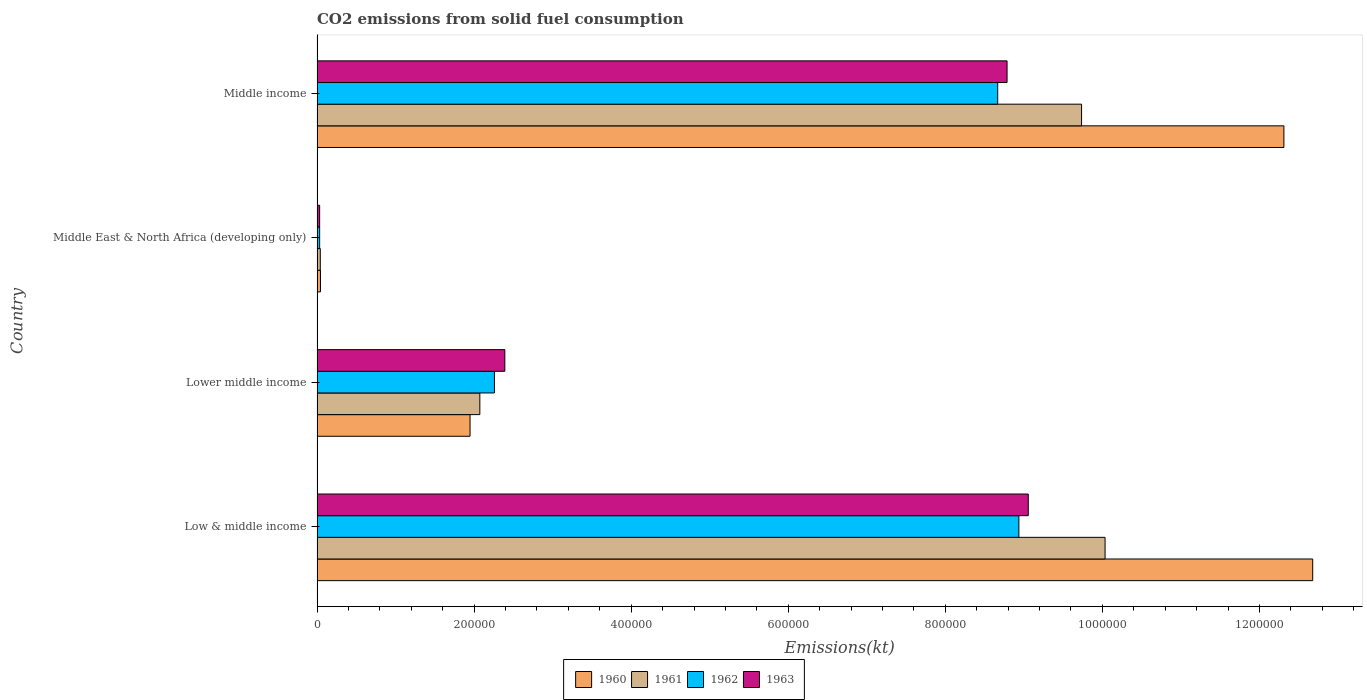Are the number of bars on each tick of the Y-axis equal?
Give a very brief answer. Yes. How many bars are there on the 1st tick from the bottom?
Provide a succinct answer. 4. In how many cases, is the number of bars for a given country not equal to the number of legend labels?
Your answer should be compact. 0. What is the amount of CO2 emitted in 1962 in Middle income?
Make the answer very short. 8.67e+05. Across all countries, what is the maximum amount of CO2 emitted in 1963?
Provide a succinct answer. 9.06e+05. Across all countries, what is the minimum amount of CO2 emitted in 1962?
Your response must be concise. 3311.16. In which country was the amount of CO2 emitted in 1961 minimum?
Your answer should be very brief. Middle East & North Africa (developing only). What is the total amount of CO2 emitted in 1962 in the graph?
Keep it short and to the point. 1.99e+06. What is the difference between the amount of CO2 emitted in 1961 in Low & middle income and that in Middle income?
Ensure brevity in your answer.  2.99e+04. What is the difference between the amount of CO2 emitted in 1962 in Middle income and the amount of CO2 emitted in 1960 in Middle East & North Africa (developing only)?
Your answer should be compact. 8.62e+05. What is the average amount of CO2 emitted in 1960 per country?
Make the answer very short. 6.75e+05. What is the difference between the amount of CO2 emitted in 1962 and amount of CO2 emitted in 1963 in Middle East & North Africa (developing only)?
Provide a succinct answer. 9.42. In how many countries, is the amount of CO2 emitted in 1963 greater than 240000 kt?
Your response must be concise. 2. What is the ratio of the amount of CO2 emitted in 1961 in Low & middle income to that in Middle East & North Africa (developing only)?
Your answer should be very brief. 244.6. What is the difference between the highest and the second highest amount of CO2 emitted in 1962?
Offer a terse response. 2.70e+04. What is the difference between the highest and the lowest amount of CO2 emitted in 1961?
Give a very brief answer. 9.99e+05. In how many countries, is the amount of CO2 emitted in 1963 greater than the average amount of CO2 emitted in 1963 taken over all countries?
Your response must be concise. 2. Is the sum of the amount of CO2 emitted in 1963 in Lower middle income and Middle East & North Africa (developing only) greater than the maximum amount of CO2 emitted in 1962 across all countries?
Make the answer very short. No. Is it the case that in every country, the sum of the amount of CO2 emitted in 1960 and amount of CO2 emitted in 1962 is greater than the sum of amount of CO2 emitted in 1963 and amount of CO2 emitted in 1961?
Offer a very short reply. No. Is it the case that in every country, the sum of the amount of CO2 emitted in 1960 and amount of CO2 emitted in 1961 is greater than the amount of CO2 emitted in 1963?
Keep it short and to the point. Yes. How many bars are there?
Your response must be concise. 16. Does the graph contain any zero values?
Offer a terse response. No. Where does the legend appear in the graph?
Offer a very short reply. Bottom center. How are the legend labels stacked?
Offer a very short reply. Horizontal. What is the title of the graph?
Ensure brevity in your answer.  CO2 emissions from solid fuel consumption. Does "1990" appear as one of the legend labels in the graph?
Offer a very short reply. No. What is the label or title of the X-axis?
Your response must be concise. Emissions(kt). What is the Emissions(kt) in 1960 in Low & middle income?
Offer a very short reply. 1.27e+06. What is the Emissions(kt) in 1961 in Low & middle income?
Offer a very short reply. 1.00e+06. What is the Emissions(kt) in 1962 in Low & middle income?
Provide a succinct answer. 8.94e+05. What is the Emissions(kt) in 1963 in Low & middle income?
Your answer should be compact. 9.06e+05. What is the Emissions(kt) in 1960 in Lower middle income?
Give a very brief answer. 1.95e+05. What is the Emissions(kt) of 1961 in Lower middle income?
Make the answer very short. 2.07e+05. What is the Emissions(kt) of 1962 in Lower middle income?
Offer a very short reply. 2.26e+05. What is the Emissions(kt) of 1963 in Lower middle income?
Give a very brief answer. 2.39e+05. What is the Emissions(kt) of 1960 in Middle East & North Africa (developing only)?
Your answer should be very brief. 4356.8. What is the Emissions(kt) of 1961 in Middle East & North Africa (developing only)?
Give a very brief answer. 4102.45. What is the Emissions(kt) in 1962 in Middle East & North Africa (developing only)?
Offer a very short reply. 3311.16. What is the Emissions(kt) of 1963 in Middle East & North Africa (developing only)?
Your answer should be compact. 3301.74. What is the Emissions(kt) of 1960 in Middle income?
Keep it short and to the point. 1.23e+06. What is the Emissions(kt) of 1961 in Middle income?
Give a very brief answer. 9.74e+05. What is the Emissions(kt) of 1962 in Middle income?
Provide a succinct answer. 8.67e+05. What is the Emissions(kt) in 1963 in Middle income?
Make the answer very short. 8.79e+05. Across all countries, what is the maximum Emissions(kt) of 1960?
Offer a very short reply. 1.27e+06. Across all countries, what is the maximum Emissions(kt) in 1961?
Ensure brevity in your answer.  1.00e+06. Across all countries, what is the maximum Emissions(kt) of 1962?
Offer a very short reply. 8.94e+05. Across all countries, what is the maximum Emissions(kt) in 1963?
Make the answer very short. 9.06e+05. Across all countries, what is the minimum Emissions(kt) in 1960?
Your answer should be very brief. 4356.8. Across all countries, what is the minimum Emissions(kt) in 1961?
Offer a terse response. 4102.45. Across all countries, what is the minimum Emissions(kt) in 1962?
Your answer should be compact. 3311.16. Across all countries, what is the minimum Emissions(kt) of 1963?
Offer a very short reply. 3301.74. What is the total Emissions(kt) in 1960 in the graph?
Keep it short and to the point. 2.70e+06. What is the total Emissions(kt) in 1961 in the graph?
Your answer should be compact. 2.19e+06. What is the total Emissions(kt) of 1962 in the graph?
Your answer should be very brief. 1.99e+06. What is the total Emissions(kt) in 1963 in the graph?
Keep it short and to the point. 2.03e+06. What is the difference between the Emissions(kt) of 1960 in Low & middle income and that in Lower middle income?
Provide a short and direct response. 1.07e+06. What is the difference between the Emissions(kt) of 1961 in Low & middle income and that in Lower middle income?
Provide a succinct answer. 7.96e+05. What is the difference between the Emissions(kt) in 1962 in Low & middle income and that in Lower middle income?
Your answer should be very brief. 6.68e+05. What is the difference between the Emissions(kt) in 1963 in Low & middle income and that in Lower middle income?
Your response must be concise. 6.67e+05. What is the difference between the Emissions(kt) of 1960 in Low & middle income and that in Middle East & North Africa (developing only)?
Ensure brevity in your answer.  1.26e+06. What is the difference between the Emissions(kt) of 1961 in Low & middle income and that in Middle East & North Africa (developing only)?
Your response must be concise. 9.99e+05. What is the difference between the Emissions(kt) in 1962 in Low & middle income and that in Middle East & North Africa (developing only)?
Your response must be concise. 8.90e+05. What is the difference between the Emissions(kt) in 1963 in Low & middle income and that in Middle East & North Africa (developing only)?
Make the answer very short. 9.02e+05. What is the difference between the Emissions(kt) of 1960 in Low & middle income and that in Middle income?
Offer a very short reply. 3.67e+04. What is the difference between the Emissions(kt) of 1961 in Low & middle income and that in Middle income?
Make the answer very short. 2.99e+04. What is the difference between the Emissions(kt) of 1962 in Low & middle income and that in Middle income?
Your response must be concise. 2.70e+04. What is the difference between the Emissions(kt) of 1963 in Low & middle income and that in Middle income?
Ensure brevity in your answer.  2.70e+04. What is the difference between the Emissions(kt) of 1960 in Lower middle income and that in Middle East & North Africa (developing only)?
Offer a terse response. 1.90e+05. What is the difference between the Emissions(kt) of 1961 in Lower middle income and that in Middle East & North Africa (developing only)?
Give a very brief answer. 2.03e+05. What is the difference between the Emissions(kt) of 1962 in Lower middle income and that in Middle East & North Africa (developing only)?
Keep it short and to the point. 2.23e+05. What is the difference between the Emissions(kt) in 1963 in Lower middle income and that in Middle East & North Africa (developing only)?
Provide a succinct answer. 2.36e+05. What is the difference between the Emissions(kt) in 1960 in Lower middle income and that in Middle income?
Keep it short and to the point. -1.04e+06. What is the difference between the Emissions(kt) in 1961 in Lower middle income and that in Middle income?
Give a very brief answer. -7.66e+05. What is the difference between the Emissions(kt) in 1962 in Lower middle income and that in Middle income?
Make the answer very short. -6.41e+05. What is the difference between the Emissions(kt) of 1963 in Lower middle income and that in Middle income?
Give a very brief answer. -6.40e+05. What is the difference between the Emissions(kt) of 1960 in Middle East & North Africa (developing only) and that in Middle income?
Ensure brevity in your answer.  -1.23e+06. What is the difference between the Emissions(kt) of 1961 in Middle East & North Africa (developing only) and that in Middle income?
Your answer should be compact. -9.69e+05. What is the difference between the Emissions(kt) in 1962 in Middle East & North Africa (developing only) and that in Middle income?
Make the answer very short. -8.63e+05. What is the difference between the Emissions(kt) of 1963 in Middle East & North Africa (developing only) and that in Middle income?
Your answer should be compact. -8.75e+05. What is the difference between the Emissions(kt) in 1960 in Low & middle income and the Emissions(kt) in 1961 in Lower middle income?
Provide a succinct answer. 1.06e+06. What is the difference between the Emissions(kt) in 1960 in Low & middle income and the Emissions(kt) in 1962 in Lower middle income?
Ensure brevity in your answer.  1.04e+06. What is the difference between the Emissions(kt) in 1960 in Low & middle income and the Emissions(kt) in 1963 in Lower middle income?
Make the answer very short. 1.03e+06. What is the difference between the Emissions(kt) in 1961 in Low & middle income and the Emissions(kt) in 1962 in Lower middle income?
Make the answer very short. 7.78e+05. What is the difference between the Emissions(kt) of 1961 in Low & middle income and the Emissions(kt) of 1963 in Lower middle income?
Offer a terse response. 7.64e+05. What is the difference between the Emissions(kt) in 1962 in Low & middle income and the Emissions(kt) in 1963 in Lower middle income?
Ensure brevity in your answer.  6.55e+05. What is the difference between the Emissions(kt) of 1960 in Low & middle income and the Emissions(kt) of 1961 in Middle East & North Africa (developing only)?
Keep it short and to the point. 1.26e+06. What is the difference between the Emissions(kt) in 1960 in Low & middle income and the Emissions(kt) in 1962 in Middle East & North Africa (developing only)?
Your answer should be very brief. 1.26e+06. What is the difference between the Emissions(kt) of 1960 in Low & middle income and the Emissions(kt) of 1963 in Middle East & North Africa (developing only)?
Make the answer very short. 1.26e+06. What is the difference between the Emissions(kt) of 1961 in Low & middle income and the Emissions(kt) of 1962 in Middle East & North Africa (developing only)?
Your answer should be compact. 1.00e+06. What is the difference between the Emissions(kt) in 1961 in Low & middle income and the Emissions(kt) in 1963 in Middle East & North Africa (developing only)?
Provide a short and direct response. 1.00e+06. What is the difference between the Emissions(kt) of 1962 in Low & middle income and the Emissions(kt) of 1963 in Middle East & North Africa (developing only)?
Ensure brevity in your answer.  8.90e+05. What is the difference between the Emissions(kt) of 1960 in Low & middle income and the Emissions(kt) of 1961 in Middle income?
Make the answer very short. 2.94e+05. What is the difference between the Emissions(kt) in 1960 in Low & middle income and the Emissions(kt) in 1962 in Middle income?
Your response must be concise. 4.01e+05. What is the difference between the Emissions(kt) of 1960 in Low & middle income and the Emissions(kt) of 1963 in Middle income?
Keep it short and to the point. 3.89e+05. What is the difference between the Emissions(kt) in 1961 in Low & middle income and the Emissions(kt) in 1962 in Middle income?
Your answer should be very brief. 1.37e+05. What is the difference between the Emissions(kt) of 1961 in Low & middle income and the Emissions(kt) of 1963 in Middle income?
Offer a terse response. 1.25e+05. What is the difference between the Emissions(kt) in 1962 in Low & middle income and the Emissions(kt) in 1963 in Middle income?
Keep it short and to the point. 1.51e+04. What is the difference between the Emissions(kt) in 1960 in Lower middle income and the Emissions(kt) in 1961 in Middle East & North Africa (developing only)?
Offer a very short reply. 1.91e+05. What is the difference between the Emissions(kt) of 1960 in Lower middle income and the Emissions(kt) of 1962 in Middle East & North Africa (developing only)?
Your answer should be compact. 1.91e+05. What is the difference between the Emissions(kt) in 1960 in Lower middle income and the Emissions(kt) in 1963 in Middle East & North Africa (developing only)?
Make the answer very short. 1.92e+05. What is the difference between the Emissions(kt) in 1961 in Lower middle income and the Emissions(kt) in 1962 in Middle East & North Africa (developing only)?
Provide a short and direct response. 2.04e+05. What is the difference between the Emissions(kt) of 1961 in Lower middle income and the Emissions(kt) of 1963 in Middle East & North Africa (developing only)?
Keep it short and to the point. 2.04e+05. What is the difference between the Emissions(kt) of 1962 in Lower middle income and the Emissions(kt) of 1963 in Middle East & North Africa (developing only)?
Your response must be concise. 2.23e+05. What is the difference between the Emissions(kt) of 1960 in Lower middle income and the Emissions(kt) of 1961 in Middle income?
Your response must be concise. -7.79e+05. What is the difference between the Emissions(kt) of 1960 in Lower middle income and the Emissions(kt) of 1962 in Middle income?
Your response must be concise. -6.72e+05. What is the difference between the Emissions(kt) in 1960 in Lower middle income and the Emissions(kt) in 1963 in Middle income?
Make the answer very short. -6.84e+05. What is the difference between the Emissions(kt) of 1961 in Lower middle income and the Emissions(kt) of 1962 in Middle income?
Keep it short and to the point. -6.59e+05. What is the difference between the Emissions(kt) of 1961 in Lower middle income and the Emissions(kt) of 1963 in Middle income?
Give a very brief answer. -6.71e+05. What is the difference between the Emissions(kt) of 1962 in Lower middle income and the Emissions(kt) of 1963 in Middle income?
Provide a short and direct response. -6.53e+05. What is the difference between the Emissions(kt) of 1960 in Middle East & North Africa (developing only) and the Emissions(kt) of 1961 in Middle income?
Your answer should be compact. -9.69e+05. What is the difference between the Emissions(kt) in 1960 in Middle East & North Africa (developing only) and the Emissions(kt) in 1962 in Middle income?
Offer a terse response. -8.62e+05. What is the difference between the Emissions(kt) in 1960 in Middle East & North Africa (developing only) and the Emissions(kt) in 1963 in Middle income?
Provide a succinct answer. -8.74e+05. What is the difference between the Emissions(kt) of 1961 in Middle East & North Africa (developing only) and the Emissions(kt) of 1962 in Middle income?
Make the answer very short. -8.63e+05. What is the difference between the Emissions(kt) of 1961 in Middle East & North Africa (developing only) and the Emissions(kt) of 1963 in Middle income?
Offer a very short reply. -8.75e+05. What is the difference between the Emissions(kt) of 1962 in Middle East & North Africa (developing only) and the Emissions(kt) of 1963 in Middle income?
Offer a very short reply. -8.75e+05. What is the average Emissions(kt) in 1960 per country?
Offer a terse response. 6.75e+05. What is the average Emissions(kt) of 1961 per country?
Give a very brief answer. 5.47e+05. What is the average Emissions(kt) of 1962 per country?
Provide a short and direct response. 4.97e+05. What is the average Emissions(kt) in 1963 per country?
Keep it short and to the point. 5.07e+05. What is the difference between the Emissions(kt) of 1960 and Emissions(kt) of 1961 in Low & middle income?
Provide a short and direct response. 2.64e+05. What is the difference between the Emissions(kt) in 1960 and Emissions(kt) in 1962 in Low & middle income?
Ensure brevity in your answer.  3.74e+05. What is the difference between the Emissions(kt) in 1960 and Emissions(kt) in 1963 in Low & middle income?
Give a very brief answer. 3.62e+05. What is the difference between the Emissions(kt) of 1961 and Emissions(kt) of 1962 in Low & middle income?
Provide a short and direct response. 1.10e+05. What is the difference between the Emissions(kt) of 1961 and Emissions(kt) of 1963 in Low & middle income?
Offer a very short reply. 9.78e+04. What is the difference between the Emissions(kt) of 1962 and Emissions(kt) of 1963 in Low & middle income?
Give a very brief answer. -1.20e+04. What is the difference between the Emissions(kt) of 1960 and Emissions(kt) of 1961 in Lower middle income?
Your answer should be very brief. -1.25e+04. What is the difference between the Emissions(kt) of 1960 and Emissions(kt) of 1962 in Lower middle income?
Provide a succinct answer. -3.10e+04. What is the difference between the Emissions(kt) in 1960 and Emissions(kt) in 1963 in Lower middle income?
Provide a short and direct response. -4.43e+04. What is the difference between the Emissions(kt) of 1961 and Emissions(kt) of 1962 in Lower middle income?
Give a very brief answer. -1.86e+04. What is the difference between the Emissions(kt) in 1961 and Emissions(kt) in 1963 in Lower middle income?
Give a very brief answer. -3.18e+04. What is the difference between the Emissions(kt) in 1962 and Emissions(kt) in 1963 in Lower middle income?
Your answer should be very brief. -1.32e+04. What is the difference between the Emissions(kt) in 1960 and Emissions(kt) in 1961 in Middle East & North Africa (developing only)?
Make the answer very short. 254.34. What is the difference between the Emissions(kt) of 1960 and Emissions(kt) of 1962 in Middle East & North Africa (developing only)?
Make the answer very short. 1045.63. What is the difference between the Emissions(kt) of 1960 and Emissions(kt) of 1963 in Middle East & North Africa (developing only)?
Offer a very short reply. 1055.05. What is the difference between the Emissions(kt) in 1961 and Emissions(kt) in 1962 in Middle East & North Africa (developing only)?
Provide a succinct answer. 791.29. What is the difference between the Emissions(kt) of 1961 and Emissions(kt) of 1963 in Middle East & North Africa (developing only)?
Provide a succinct answer. 800.71. What is the difference between the Emissions(kt) of 1962 and Emissions(kt) of 1963 in Middle East & North Africa (developing only)?
Offer a terse response. 9.42. What is the difference between the Emissions(kt) in 1960 and Emissions(kt) in 1961 in Middle income?
Offer a terse response. 2.58e+05. What is the difference between the Emissions(kt) in 1960 and Emissions(kt) in 1962 in Middle income?
Make the answer very short. 3.64e+05. What is the difference between the Emissions(kt) in 1960 and Emissions(kt) in 1963 in Middle income?
Give a very brief answer. 3.53e+05. What is the difference between the Emissions(kt) in 1961 and Emissions(kt) in 1962 in Middle income?
Give a very brief answer. 1.07e+05. What is the difference between the Emissions(kt) in 1961 and Emissions(kt) in 1963 in Middle income?
Make the answer very short. 9.49e+04. What is the difference between the Emissions(kt) in 1962 and Emissions(kt) in 1963 in Middle income?
Ensure brevity in your answer.  -1.19e+04. What is the ratio of the Emissions(kt) of 1960 in Low & middle income to that in Lower middle income?
Offer a terse response. 6.51. What is the ratio of the Emissions(kt) in 1961 in Low & middle income to that in Lower middle income?
Provide a succinct answer. 4.84. What is the ratio of the Emissions(kt) in 1962 in Low & middle income to that in Lower middle income?
Provide a short and direct response. 3.96. What is the ratio of the Emissions(kt) in 1963 in Low & middle income to that in Lower middle income?
Provide a succinct answer. 3.79. What is the ratio of the Emissions(kt) in 1960 in Low & middle income to that in Middle East & North Africa (developing only)?
Keep it short and to the point. 291. What is the ratio of the Emissions(kt) of 1961 in Low & middle income to that in Middle East & North Africa (developing only)?
Your answer should be very brief. 244.6. What is the ratio of the Emissions(kt) of 1962 in Low & middle income to that in Middle East & North Africa (developing only)?
Your answer should be very brief. 269.9. What is the ratio of the Emissions(kt) in 1963 in Low & middle income to that in Middle East & North Africa (developing only)?
Make the answer very short. 274.29. What is the ratio of the Emissions(kt) in 1960 in Low & middle income to that in Middle income?
Provide a short and direct response. 1.03. What is the ratio of the Emissions(kt) in 1961 in Low & middle income to that in Middle income?
Your response must be concise. 1.03. What is the ratio of the Emissions(kt) of 1962 in Low & middle income to that in Middle income?
Your answer should be compact. 1.03. What is the ratio of the Emissions(kt) of 1963 in Low & middle income to that in Middle income?
Ensure brevity in your answer.  1.03. What is the ratio of the Emissions(kt) of 1960 in Lower middle income to that in Middle East & North Africa (developing only)?
Your answer should be compact. 44.71. What is the ratio of the Emissions(kt) in 1961 in Lower middle income to that in Middle East & North Africa (developing only)?
Your answer should be very brief. 50.53. What is the ratio of the Emissions(kt) of 1962 in Lower middle income to that in Middle East & North Africa (developing only)?
Provide a succinct answer. 68.21. What is the ratio of the Emissions(kt) in 1963 in Lower middle income to that in Middle East & North Africa (developing only)?
Your response must be concise. 72.42. What is the ratio of the Emissions(kt) of 1960 in Lower middle income to that in Middle income?
Your answer should be very brief. 0.16. What is the ratio of the Emissions(kt) in 1961 in Lower middle income to that in Middle income?
Offer a very short reply. 0.21. What is the ratio of the Emissions(kt) of 1962 in Lower middle income to that in Middle income?
Give a very brief answer. 0.26. What is the ratio of the Emissions(kt) of 1963 in Lower middle income to that in Middle income?
Keep it short and to the point. 0.27. What is the ratio of the Emissions(kt) in 1960 in Middle East & North Africa (developing only) to that in Middle income?
Ensure brevity in your answer.  0. What is the ratio of the Emissions(kt) in 1961 in Middle East & North Africa (developing only) to that in Middle income?
Offer a terse response. 0. What is the ratio of the Emissions(kt) of 1962 in Middle East & North Africa (developing only) to that in Middle income?
Ensure brevity in your answer.  0. What is the ratio of the Emissions(kt) in 1963 in Middle East & North Africa (developing only) to that in Middle income?
Make the answer very short. 0. What is the difference between the highest and the second highest Emissions(kt) of 1960?
Ensure brevity in your answer.  3.67e+04. What is the difference between the highest and the second highest Emissions(kt) of 1961?
Your answer should be compact. 2.99e+04. What is the difference between the highest and the second highest Emissions(kt) of 1962?
Your answer should be compact. 2.70e+04. What is the difference between the highest and the second highest Emissions(kt) in 1963?
Offer a very short reply. 2.70e+04. What is the difference between the highest and the lowest Emissions(kt) in 1960?
Give a very brief answer. 1.26e+06. What is the difference between the highest and the lowest Emissions(kt) of 1961?
Offer a very short reply. 9.99e+05. What is the difference between the highest and the lowest Emissions(kt) of 1962?
Ensure brevity in your answer.  8.90e+05. What is the difference between the highest and the lowest Emissions(kt) of 1963?
Ensure brevity in your answer.  9.02e+05. 